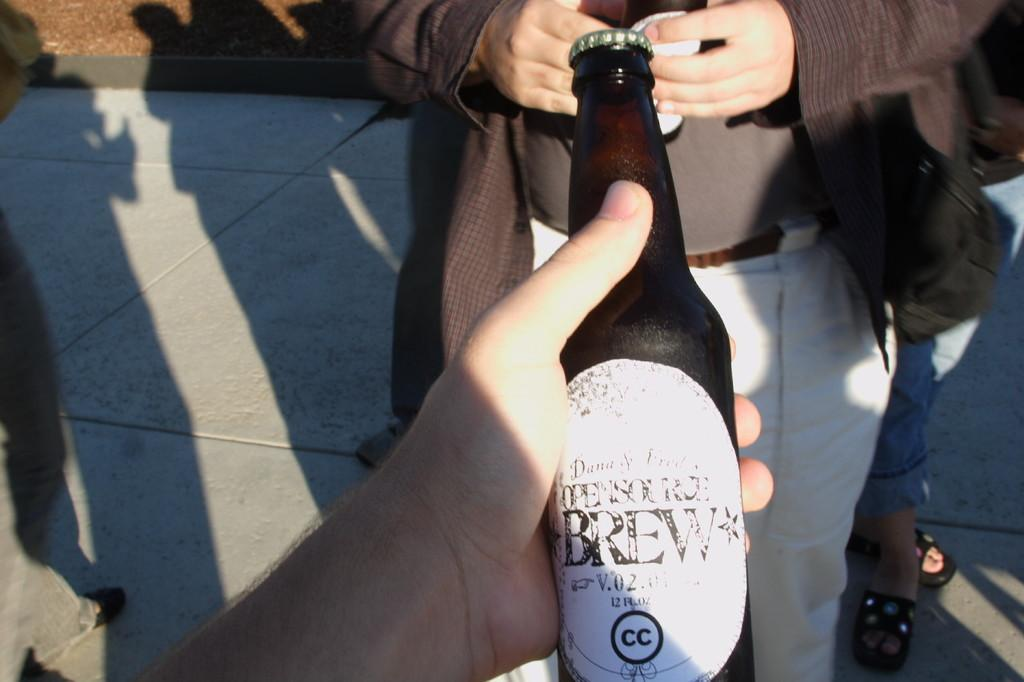How many people are in the image? There are two persons in the image. What is one of the persons holding? One of the persons is holding a glass bottle. What type of bird can be seen flying over the stream in the image? There is no bird or stream present in the image; it only features two persons, one of whom is holding a glass bottle. 